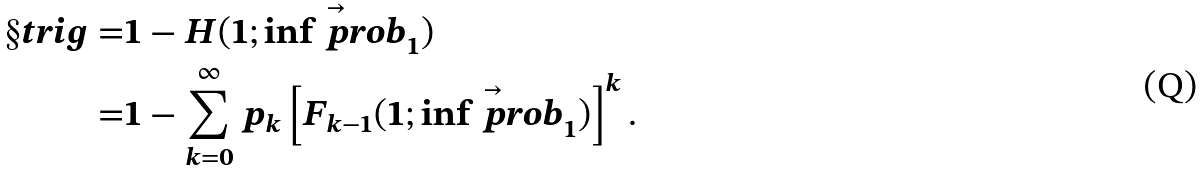<formula> <loc_0><loc_0><loc_500><loc_500>\S t r i g = & 1 - H ( 1 ; \vec { \inf p r o b } _ { 1 } ) \\ = & 1 - \sum _ { k = 0 } ^ { \infty } p _ { k } \left [ F _ { k - 1 } ( 1 ; \vec { \inf p r o b } _ { 1 } ) \right ] ^ { k } .</formula> 